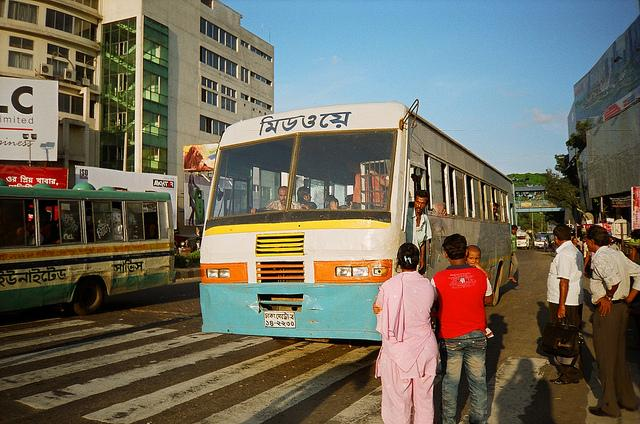What is the man with mustache about to do?

Choices:
A) board bus
B) sightseeing
C) block people
D) get off get off 